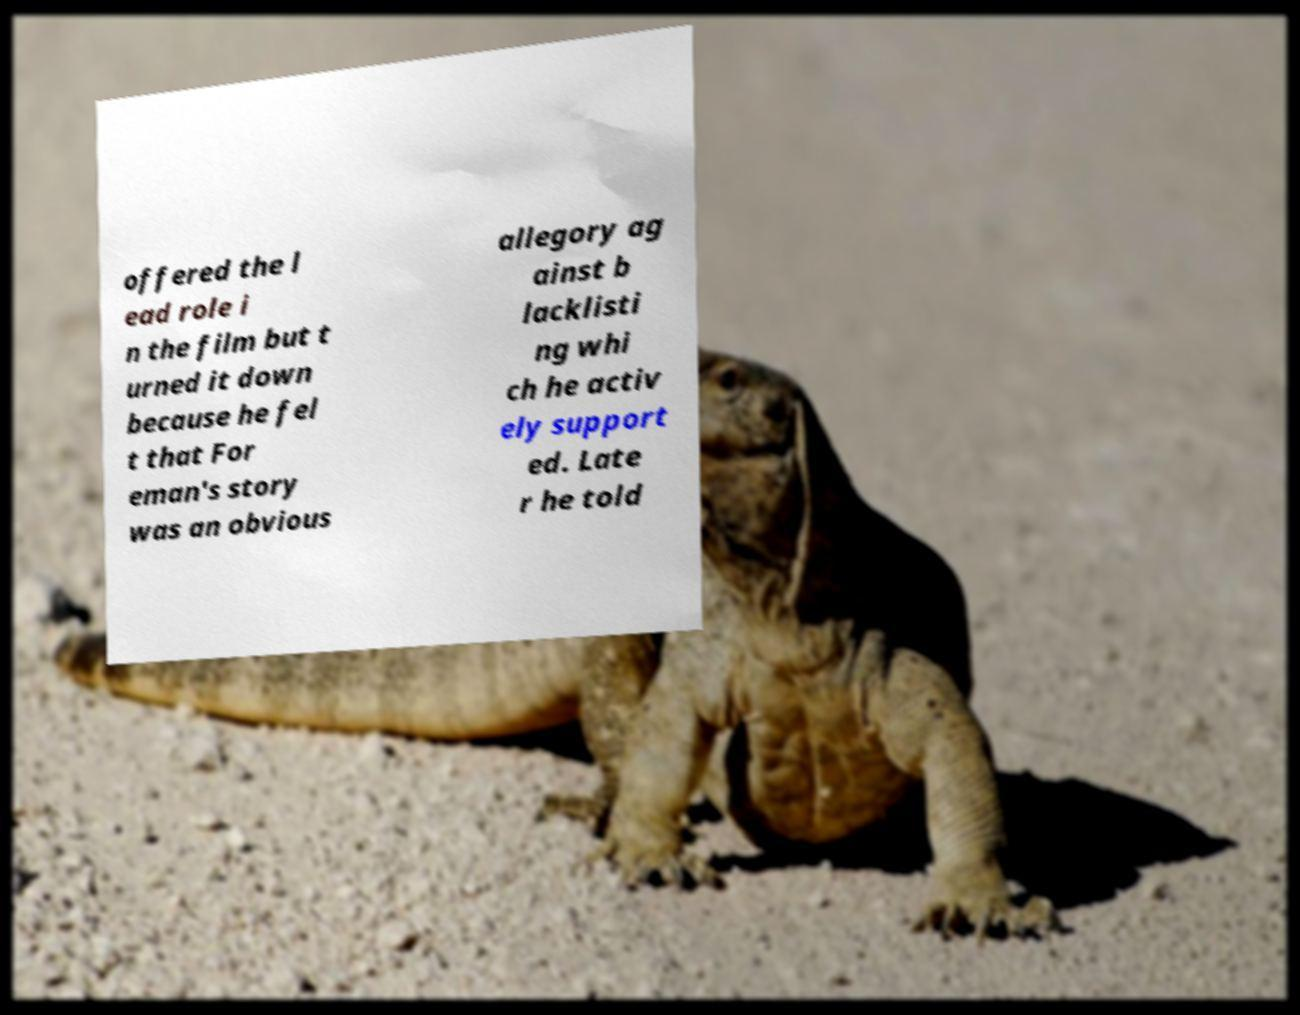Please identify and transcribe the text found in this image. offered the l ead role i n the film but t urned it down because he fel t that For eman's story was an obvious allegory ag ainst b lacklisti ng whi ch he activ ely support ed. Late r he told 